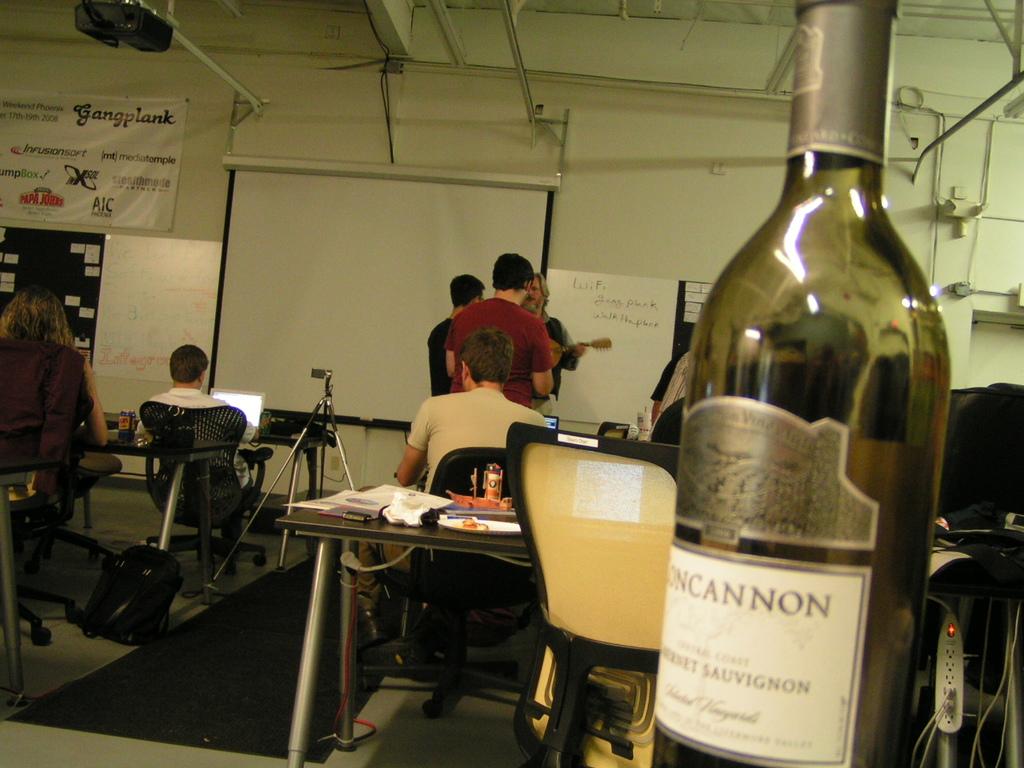What type of wine is that ?
Give a very brief answer. Cabernet sauvignon. 